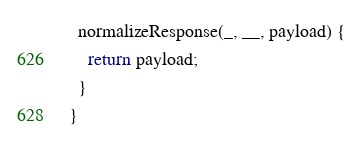<code> <loc_0><loc_0><loc_500><loc_500><_JavaScript_>  normalizeResponse(_, __, payload) {
    return payload;
  }
}
</code> 